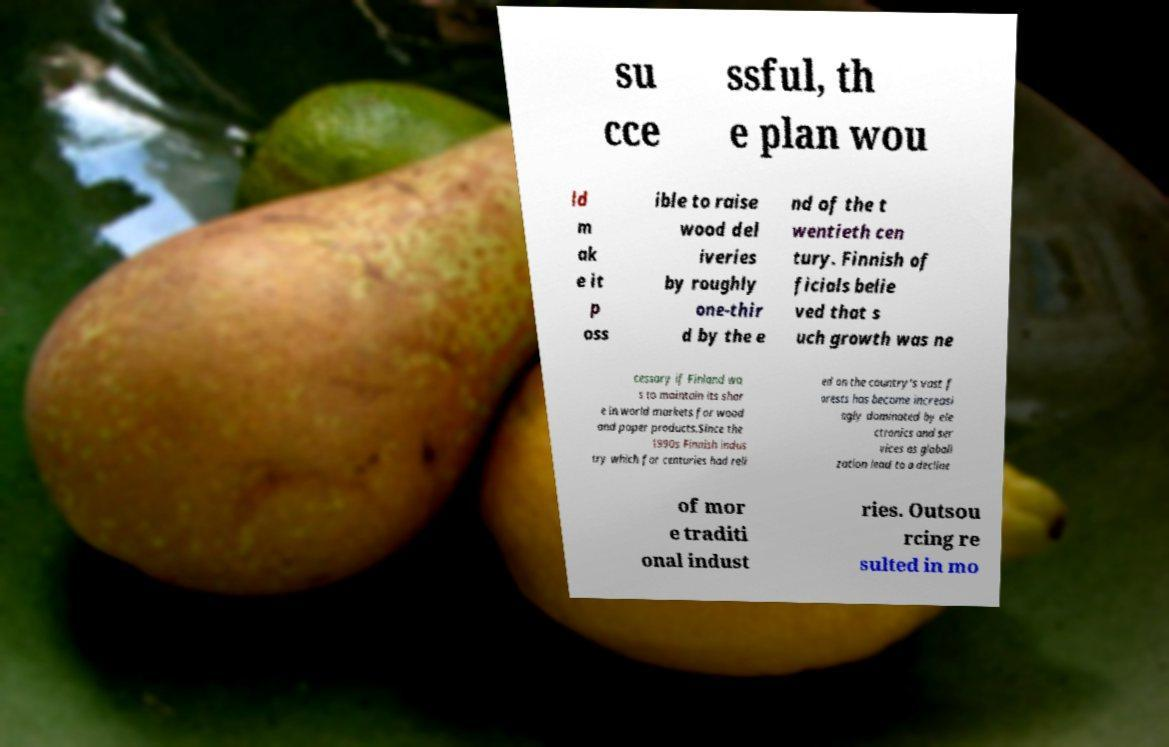Can you accurately transcribe the text from the provided image for me? su cce ssful, th e plan wou ld m ak e it p oss ible to raise wood del iveries by roughly one-thir d by the e nd of the t wentieth cen tury. Finnish of ficials belie ved that s uch growth was ne cessary if Finland wa s to maintain its shar e in world markets for wood and paper products.Since the 1990s Finnish indus try which for centuries had reli ed on the country's vast f orests has become increasi ngly dominated by ele ctronics and ser vices as globali zation lead to a decline of mor e traditi onal indust ries. Outsou rcing re sulted in mo 